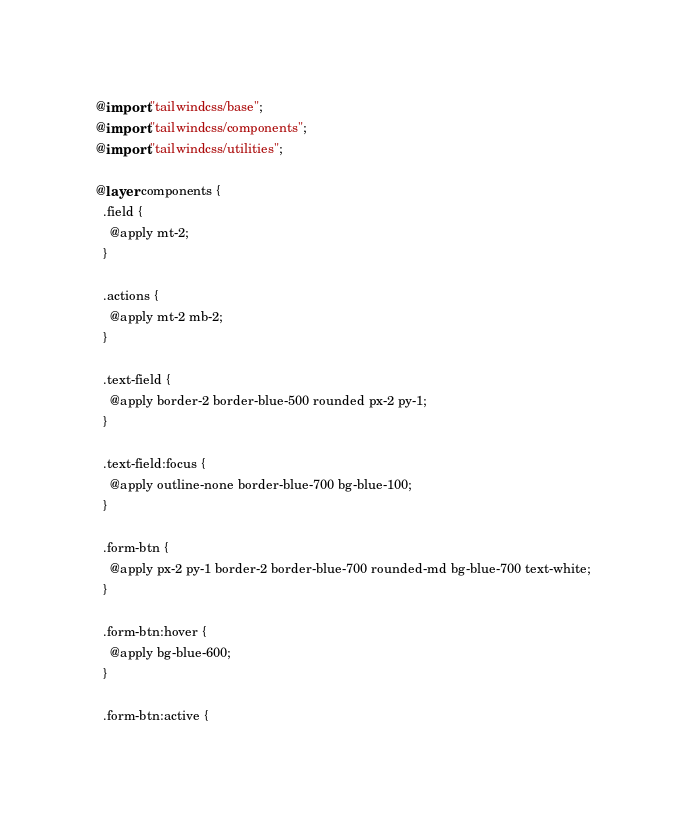Convert code to text. <code><loc_0><loc_0><loc_500><loc_500><_CSS_>@import "tailwindcss/base";
@import "tailwindcss/components";
@import "tailwindcss/utilities";

@layer components {
  .field {
    @apply mt-2;
  }

  .actions {
    @apply mt-2 mb-2;
  }

  .text-field {
    @apply border-2 border-blue-500 rounded px-2 py-1;
  }

  .text-field:focus {
    @apply outline-none border-blue-700 bg-blue-100;
  }

  .form-btn {
    @apply px-2 py-1 border-2 border-blue-700 rounded-md bg-blue-700 text-white;
  }

  .form-btn:hover {
    @apply bg-blue-600;
  }

  .form-btn:active {</code> 